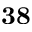Convert formula to latex. <formula><loc_0><loc_0><loc_500><loc_500>3 8</formula> 